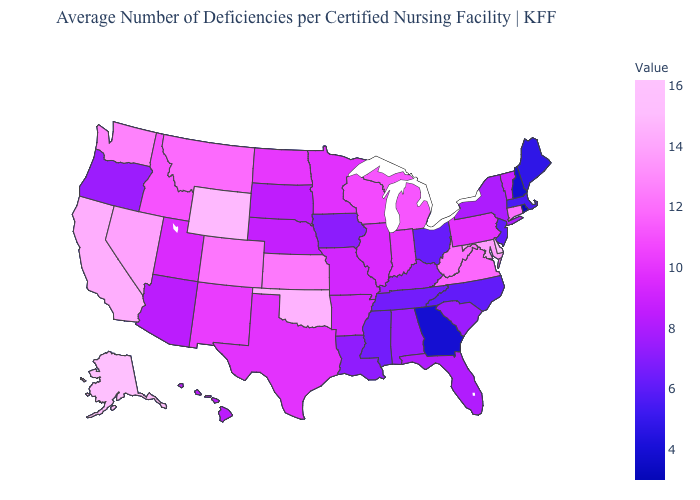Is the legend a continuous bar?
Keep it brief. Yes. Does Alabama have the lowest value in the USA?
Write a very short answer. No. Among the states that border Illinois , which have the highest value?
Write a very short answer. Wisconsin. 